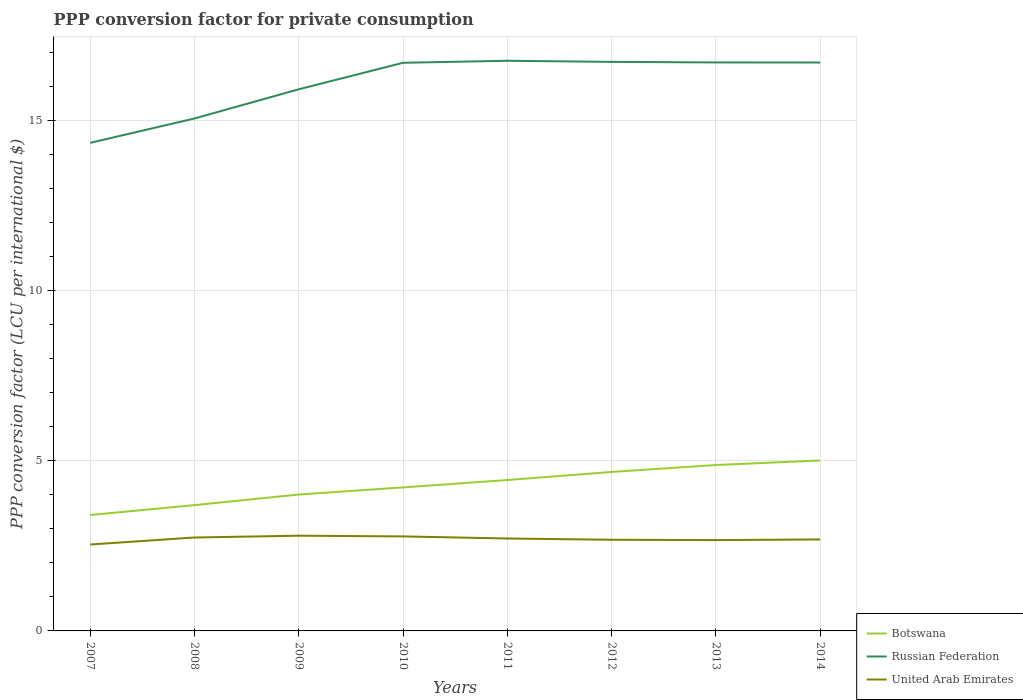Does the line corresponding to Botswana intersect with the line corresponding to United Arab Emirates?
Make the answer very short. No. Across all years, what is the maximum PPP conversion factor for private consumption in Botswana?
Ensure brevity in your answer.  3.41. What is the total PPP conversion factor for private consumption in Russian Federation in the graph?
Your answer should be compact. 0. What is the difference between the highest and the second highest PPP conversion factor for private consumption in Russian Federation?
Provide a short and direct response. 2.41. What is the difference between the highest and the lowest PPP conversion factor for private consumption in Russian Federation?
Your response must be concise. 5. How many lines are there?
Your answer should be very brief. 3. How many years are there in the graph?
Offer a terse response. 8. Does the graph contain any zero values?
Ensure brevity in your answer.  No. How many legend labels are there?
Make the answer very short. 3. How are the legend labels stacked?
Offer a very short reply. Vertical. What is the title of the graph?
Your answer should be very brief. PPP conversion factor for private consumption. Does "Latin America(developing only)" appear as one of the legend labels in the graph?
Give a very brief answer. No. What is the label or title of the Y-axis?
Offer a terse response. PPP conversion factor (LCU per international $). What is the PPP conversion factor (LCU per international $) in Botswana in 2007?
Give a very brief answer. 3.41. What is the PPP conversion factor (LCU per international $) in Russian Federation in 2007?
Provide a succinct answer. 14.36. What is the PPP conversion factor (LCU per international $) in United Arab Emirates in 2007?
Provide a succinct answer. 2.54. What is the PPP conversion factor (LCU per international $) of Botswana in 2008?
Keep it short and to the point. 3.7. What is the PPP conversion factor (LCU per international $) in Russian Federation in 2008?
Offer a terse response. 15.07. What is the PPP conversion factor (LCU per international $) of United Arab Emirates in 2008?
Your answer should be compact. 2.75. What is the PPP conversion factor (LCU per international $) of Botswana in 2009?
Offer a terse response. 4.01. What is the PPP conversion factor (LCU per international $) of Russian Federation in 2009?
Provide a short and direct response. 15.93. What is the PPP conversion factor (LCU per international $) in United Arab Emirates in 2009?
Make the answer very short. 2.8. What is the PPP conversion factor (LCU per international $) in Botswana in 2010?
Your response must be concise. 4.22. What is the PPP conversion factor (LCU per international $) of Russian Federation in 2010?
Provide a succinct answer. 16.71. What is the PPP conversion factor (LCU per international $) of United Arab Emirates in 2010?
Keep it short and to the point. 2.78. What is the PPP conversion factor (LCU per international $) of Botswana in 2011?
Offer a very short reply. 4.44. What is the PPP conversion factor (LCU per international $) in Russian Federation in 2011?
Provide a succinct answer. 16.77. What is the PPP conversion factor (LCU per international $) of United Arab Emirates in 2011?
Your answer should be very brief. 2.72. What is the PPP conversion factor (LCU per international $) of Botswana in 2012?
Offer a terse response. 4.68. What is the PPP conversion factor (LCU per international $) of Russian Federation in 2012?
Give a very brief answer. 16.74. What is the PPP conversion factor (LCU per international $) in United Arab Emirates in 2012?
Your answer should be very brief. 2.68. What is the PPP conversion factor (LCU per international $) of Botswana in 2013?
Ensure brevity in your answer.  4.88. What is the PPP conversion factor (LCU per international $) of Russian Federation in 2013?
Offer a terse response. 16.72. What is the PPP conversion factor (LCU per international $) in United Arab Emirates in 2013?
Keep it short and to the point. 2.67. What is the PPP conversion factor (LCU per international $) in Botswana in 2014?
Give a very brief answer. 5.01. What is the PPP conversion factor (LCU per international $) of Russian Federation in 2014?
Make the answer very short. 16.72. What is the PPP conversion factor (LCU per international $) of United Arab Emirates in 2014?
Provide a succinct answer. 2.69. Across all years, what is the maximum PPP conversion factor (LCU per international $) of Botswana?
Offer a terse response. 5.01. Across all years, what is the maximum PPP conversion factor (LCU per international $) in Russian Federation?
Give a very brief answer. 16.77. Across all years, what is the maximum PPP conversion factor (LCU per international $) of United Arab Emirates?
Offer a very short reply. 2.8. Across all years, what is the minimum PPP conversion factor (LCU per international $) in Botswana?
Your answer should be very brief. 3.41. Across all years, what is the minimum PPP conversion factor (LCU per international $) of Russian Federation?
Make the answer very short. 14.36. Across all years, what is the minimum PPP conversion factor (LCU per international $) in United Arab Emirates?
Your answer should be very brief. 2.54. What is the total PPP conversion factor (LCU per international $) of Botswana in the graph?
Provide a short and direct response. 34.35. What is the total PPP conversion factor (LCU per international $) of Russian Federation in the graph?
Give a very brief answer. 129.01. What is the total PPP conversion factor (LCU per international $) in United Arab Emirates in the graph?
Give a very brief answer. 21.63. What is the difference between the PPP conversion factor (LCU per international $) in Botswana in 2007 and that in 2008?
Provide a short and direct response. -0.29. What is the difference between the PPP conversion factor (LCU per international $) of Russian Federation in 2007 and that in 2008?
Provide a succinct answer. -0.72. What is the difference between the PPP conversion factor (LCU per international $) of United Arab Emirates in 2007 and that in 2008?
Offer a terse response. -0.21. What is the difference between the PPP conversion factor (LCU per international $) of Botswana in 2007 and that in 2009?
Your answer should be compact. -0.6. What is the difference between the PPP conversion factor (LCU per international $) of Russian Federation in 2007 and that in 2009?
Offer a terse response. -1.57. What is the difference between the PPP conversion factor (LCU per international $) of United Arab Emirates in 2007 and that in 2009?
Offer a terse response. -0.26. What is the difference between the PPP conversion factor (LCU per international $) in Botswana in 2007 and that in 2010?
Your answer should be very brief. -0.81. What is the difference between the PPP conversion factor (LCU per international $) of Russian Federation in 2007 and that in 2010?
Offer a very short reply. -2.35. What is the difference between the PPP conversion factor (LCU per international $) in United Arab Emirates in 2007 and that in 2010?
Your answer should be compact. -0.24. What is the difference between the PPP conversion factor (LCU per international $) in Botswana in 2007 and that in 2011?
Your response must be concise. -1.03. What is the difference between the PPP conversion factor (LCU per international $) of Russian Federation in 2007 and that in 2011?
Provide a short and direct response. -2.41. What is the difference between the PPP conversion factor (LCU per international $) of United Arab Emirates in 2007 and that in 2011?
Offer a terse response. -0.18. What is the difference between the PPP conversion factor (LCU per international $) in Botswana in 2007 and that in 2012?
Offer a terse response. -1.27. What is the difference between the PPP conversion factor (LCU per international $) in Russian Federation in 2007 and that in 2012?
Provide a short and direct response. -2.38. What is the difference between the PPP conversion factor (LCU per international $) in United Arab Emirates in 2007 and that in 2012?
Offer a very short reply. -0.14. What is the difference between the PPP conversion factor (LCU per international $) in Botswana in 2007 and that in 2013?
Keep it short and to the point. -1.47. What is the difference between the PPP conversion factor (LCU per international $) in Russian Federation in 2007 and that in 2013?
Your answer should be very brief. -2.36. What is the difference between the PPP conversion factor (LCU per international $) in United Arab Emirates in 2007 and that in 2013?
Make the answer very short. -0.13. What is the difference between the PPP conversion factor (LCU per international $) in Botswana in 2007 and that in 2014?
Provide a short and direct response. -1.6. What is the difference between the PPP conversion factor (LCU per international $) in Russian Federation in 2007 and that in 2014?
Your response must be concise. -2.36. What is the difference between the PPP conversion factor (LCU per international $) in United Arab Emirates in 2007 and that in 2014?
Ensure brevity in your answer.  -0.15. What is the difference between the PPP conversion factor (LCU per international $) of Botswana in 2008 and that in 2009?
Make the answer very short. -0.31. What is the difference between the PPP conversion factor (LCU per international $) of Russian Federation in 2008 and that in 2009?
Your response must be concise. -0.86. What is the difference between the PPP conversion factor (LCU per international $) in United Arab Emirates in 2008 and that in 2009?
Your answer should be very brief. -0.05. What is the difference between the PPP conversion factor (LCU per international $) of Botswana in 2008 and that in 2010?
Your answer should be compact. -0.52. What is the difference between the PPP conversion factor (LCU per international $) of Russian Federation in 2008 and that in 2010?
Keep it short and to the point. -1.64. What is the difference between the PPP conversion factor (LCU per international $) in United Arab Emirates in 2008 and that in 2010?
Your answer should be compact. -0.03. What is the difference between the PPP conversion factor (LCU per international $) in Botswana in 2008 and that in 2011?
Your answer should be very brief. -0.74. What is the difference between the PPP conversion factor (LCU per international $) of Russian Federation in 2008 and that in 2011?
Your response must be concise. -1.7. What is the difference between the PPP conversion factor (LCU per international $) in United Arab Emirates in 2008 and that in 2011?
Offer a terse response. 0.03. What is the difference between the PPP conversion factor (LCU per international $) in Botswana in 2008 and that in 2012?
Provide a succinct answer. -0.98. What is the difference between the PPP conversion factor (LCU per international $) in Russian Federation in 2008 and that in 2012?
Your answer should be very brief. -1.66. What is the difference between the PPP conversion factor (LCU per international $) of United Arab Emirates in 2008 and that in 2012?
Your answer should be compact. 0.07. What is the difference between the PPP conversion factor (LCU per international $) in Botswana in 2008 and that in 2013?
Make the answer very short. -1.18. What is the difference between the PPP conversion factor (LCU per international $) of Russian Federation in 2008 and that in 2013?
Your answer should be very brief. -1.65. What is the difference between the PPP conversion factor (LCU per international $) in United Arab Emirates in 2008 and that in 2013?
Provide a succinct answer. 0.08. What is the difference between the PPP conversion factor (LCU per international $) in Botswana in 2008 and that in 2014?
Your answer should be very brief. -1.31. What is the difference between the PPP conversion factor (LCU per international $) of Russian Federation in 2008 and that in 2014?
Ensure brevity in your answer.  -1.65. What is the difference between the PPP conversion factor (LCU per international $) in United Arab Emirates in 2008 and that in 2014?
Your response must be concise. 0.06. What is the difference between the PPP conversion factor (LCU per international $) of Botswana in 2009 and that in 2010?
Provide a succinct answer. -0.21. What is the difference between the PPP conversion factor (LCU per international $) in Russian Federation in 2009 and that in 2010?
Offer a terse response. -0.78. What is the difference between the PPP conversion factor (LCU per international $) of United Arab Emirates in 2009 and that in 2010?
Your answer should be very brief. 0.02. What is the difference between the PPP conversion factor (LCU per international $) of Botswana in 2009 and that in 2011?
Provide a short and direct response. -0.43. What is the difference between the PPP conversion factor (LCU per international $) in Russian Federation in 2009 and that in 2011?
Offer a terse response. -0.84. What is the difference between the PPP conversion factor (LCU per international $) of United Arab Emirates in 2009 and that in 2011?
Your answer should be very brief. 0.08. What is the difference between the PPP conversion factor (LCU per international $) of Botswana in 2009 and that in 2012?
Your answer should be very brief. -0.66. What is the difference between the PPP conversion factor (LCU per international $) of Russian Federation in 2009 and that in 2012?
Your response must be concise. -0.81. What is the difference between the PPP conversion factor (LCU per international $) in United Arab Emirates in 2009 and that in 2012?
Ensure brevity in your answer.  0.12. What is the difference between the PPP conversion factor (LCU per international $) of Botswana in 2009 and that in 2013?
Provide a short and direct response. -0.87. What is the difference between the PPP conversion factor (LCU per international $) in Russian Federation in 2009 and that in 2013?
Your answer should be very brief. -0.79. What is the difference between the PPP conversion factor (LCU per international $) of United Arab Emirates in 2009 and that in 2013?
Your answer should be very brief. 0.13. What is the difference between the PPP conversion factor (LCU per international $) in Botswana in 2009 and that in 2014?
Your answer should be compact. -1. What is the difference between the PPP conversion factor (LCU per international $) of Russian Federation in 2009 and that in 2014?
Offer a very short reply. -0.79. What is the difference between the PPP conversion factor (LCU per international $) of United Arab Emirates in 2009 and that in 2014?
Keep it short and to the point. 0.11. What is the difference between the PPP conversion factor (LCU per international $) in Botswana in 2010 and that in 2011?
Make the answer very short. -0.22. What is the difference between the PPP conversion factor (LCU per international $) of Russian Federation in 2010 and that in 2011?
Offer a terse response. -0.06. What is the difference between the PPP conversion factor (LCU per international $) of United Arab Emirates in 2010 and that in 2011?
Keep it short and to the point. 0.06. What is the difference between the PPP conversion factor (LCU per international $) of Botswana in 2010 and that in 2012?
Ensure brevity in your answer.  -0.45. What is the difference between the PPP conversion factor (LCU per international $) in Russian Federation in 2010 and that in 2012?
Ensure brevity in your answer.  -0.03. What is the difference between the PPP conversion factor (LCU per international $) of United Arab Emirates in 2010 and that in 2012?
Make the answer very short. 0.1. What is the difference between the PPP conversion factor (LCU per international $) of Botswana in 2010 and that in 2013?
Give a very brief answer. -0.66. What is the difference between the PPP conversion factor (LCU per international $) in Russian Federation in 2010 and that in 2013?
Provide a short and direct response. -0.01. What is the difference between the PPP conversion factor (LCU per international $) in United Arab Emirates in 2010 and that in 2013?
Your answer should be very brief. 0.11. What is the difference between the PPP conversion factor (LCU per international $) in Botswana in 2010 and that in 2014?
Give a very brief answer. -0.79. What is the difference between the PPP conversion factor (LCU per international $) of Russian Federation in 2010 and that in 2014?
Your response must be concise. -0.01. What is the difference between the PPP conversion factor (LCU per international $) of United Arab Emirates in 2010 and that in 2014?
Offer a very short reply. 0.09. What is the difference between the PPP conversion factor (LCU per international $) of Botswana in 2011 and that in 2012?
Offer a terse response. -0.24. What is the difference between the PPP conversion factor (LCU per international $) in Russian Federation in 2011 and that in 2012?
Offer a terse response. 0.03. What is the difference between the PPP conversion factor (LCU per international $) of United Arab Emirates in 2011 and that in 2012?
Keep it short and to the point. 0.04. What is the difference between the PPP conversion factor (LCU per international $) of Botswana in 2011 and that in 2013?
Provide a succinct answer. -0.44. What is the difference between the PPP conversion factor (LCU per international $) of Russian Federation in 2011 and that in 2013?
Offer a terse response. 0.05. What is the difference between the PPP conversion factor (LCU per international $) in United Arab Emirates in 2011 and that in 2013?
Ensure brevity in your answer.  0.05. What is the difference between the PPP conversion factor (LCU per international $) in Botswana in 2011 and that in 2014?
Make the answer very short. -0.58. What is the difference between the PPP conversion factor (LCU per international $) of Russian Federation in 2011 and that in 2014?
Offer a very short reply. 0.05. What is the difference between the PPP conversion factor (LCU per international $) in United Arab Emirates in 2011 and that in 2014?
Provide a succinct answer. 0.03. What is the difference between the PPP conversion factor (LCU per international $) in Botswana in 2012 and that in 2013?
Offer a very short reply. -0.2. What is the difference between the PPP conversion factor (LCU per international $) in Russian Federation in 2012 and that in 2013?
Provide a short and direct response. 0.02. What is the difference between the PPP conversion factor (LCU per international $) in United Arab Emirates in 2012 and that in 2013?
Keep it short and to the point. 0.01. What is the difference between the PPP conversion factor (LCU per international $) of Botswana in 2012 and that in 2014?
Offer a very short reply. -0.34. What is the difference between the PPP conversion factor (LCU per international $) in Russian Federation in 2012 and that in 2014?
Keep it short and to the point. 0.02. What is the difference between the PPP conversion factor (LCU per international $) of United Arab Emirates in 2012 and that in 2014?
Provide a succinct answer. -0.01. What is the difference between the PPP conversion factor (LCU per international $) of Botswana in 2013 and that in 2014?
Your response must be concise. -0.13. What is the difference between the PPP conversion factor (LCU per international $) in Russian Federation in 2013 and that in 2014?
Ensure brevity in your answer.  0. What is the difference between the PPP conversion factor (LCU per international $) of United Arab Emirates in 2013 and that in 2014?
Make the answer very short. -0.02. What is the difference between the PPP conversion factor (LCU per international $) in Botswana in 2007 and the PPP conversion factor (LCU per international $) in Russian Federation in 2008?
Ensure brevity in your answer.  -11.66. What is the difference between the PPP conversion factor (LCU per international $) of Botswana in 2007 and the PPP conversion factor (LCU per international $) of United Arab Emirates in 2008?
Your response must be concise. 0.66. What is the difference between the PPP conversion factor (LCU per international $) of Russian Federation in 2007 and the PPP conversion factor (LCU per international $) of United Arab Emirates in 2008?
Give a very brief answer. 11.61. What is the difference between the PPP conversion factor (LCU per international $) of Botswana in 2007 and the PPP conversion factor (LCU per international $) of Russian Federation in 2009?
Ensure brevity in your answer.  -12.52. What is the difference between the PPP conversion factor (LCU per international $) of Botswana in 2007 and the PPP conversion factor (LCU per international $) of United Arab Emirates in 2009?
Make the answer very short. 0.61. What is the difference between the PPP conversion factor (LCU per international $) of Russian Federation in 2007 and the PPP conversion factor (LCU per international $) of United Arab Emirates in 2009?
Your response must be concise. 11.55. What is the difference between the PPP conversion factor (LCU per international $) of Botswana in 2007 and the PPP conversion factor (LCU per international $) of Russian Federation in 2010?
Provide a succinct answer. -13.3. What is the difference between the PPP conversion factor (LCU per international $) of Botswana in 2007 and the PPP conversion factor (LCU per international $) of United Arab Emirates in 2010?
Keep it short and to the point. 0.63. What is the difference between the PPP conversion factor (LCU per international $) in Russian Federation in 2007 and the PPP conversion factor (LCU per international $) in United Arab Emirates in 2010?
Offer a terse response. 11.58. What is the difference between the PPP conversion factor (LCU per international $) in Botswana in 2007 and the PPP conversion factor (LCU per international $) in Russian Federation in 2011?
Ensure brevity in your answer.  -13.36. What is the difference between the PPP conversion factor (LCU per international $) in Botswana in 2007 and the PPP conversion factor (LCU per international $) in United Arab Emirates in 2011?
Your response must be concise. 0.69. What is the difference between the PPP conversion factor (LCU per international $) of Russian Federation in 2007 and the PPP conversion factor (LCU per international $) of United Arab Emirates in 2011?
Make the answer very short. 11.64. What is the difference between the PPP conversion factor (LCU per international $) of Botswana in 2007 and the PPP conversion factor (LCU per international $) of Russian Federation in 2012?
Make the answer very short. -13.33. What is the difference between the PPP conversion factor (LCU per international $) in Botswana in 2007 and the PPP conversion factor (LCU per international $) in United Arab Emirates in 2012?
Provide a short and direct response. 0.73. What is the difference between the PPP conversion factor (LCU per international $) of Russian Federation in 2007 and the PPP conversion factor (LCU per international $) of United Arab Emirates in 2012?
Offer a very short reply. 11.67. What is the difference between the PPP conversion factor (LCU per international $) of Botswana in 2007 and the PPP conversion factor (LCU per international $) of Russian Federation in 2013?
Ensure brevity in your answer.  -13.31. What is the difference between the PPP conversion factor (LCU per international $) of Botswana in 2007 and the PPP conversion factor (LCU per international $) of United Arab Emirates in 2013?
Ensure brevity in your answer.  0.74. What is the difference between the PPP conversion factor (LCU per international $) in Russian Federation in 2007 and the PPP conversion factor (LCU per international $) in United Arab Emirates in 2013?
Offer a terse response. 11.68. What is the difference between the PPP conversion factor (LCU per international $) of Botswana in 2007 and the PPP conversion factor (LCU per international $) of Russian Federation in 2014?
Your response must be concise. -13.31. What is the difference between the PPP conversion factor (LCU per international $) in Botswana in 2007 and the PPP conversion factor (LCU per international $) in United Arab Emirates in 2014?
Offer a very short reply. 0.72. What is the difference between the PPP conversion factor (LCU per international $) in Russian Federation in 2007 and the PPP conversion factor (LCU per international $) in United Arab Emirates in 2014?
Make the answer very short. 11.67. What is the difference between the PPP conversion factor (LCU per international $) in Botswana in 2008 and the PPP conversion factor (LCU per international $) in Russian Federation in 2009?
Provide a short and direct response. -12.23. What is the difference between the PPP conversion factor (LCU per international $) in Botswana in 2008 and the PPP conversion factor (LCU per international $) in United Arab Emirates in 2009?
Your answer should be compact. 0.9. What is the difference between the PPP conversion factor (LCU per international $) in Russian Federation in 2008 and the PPP conversion factor (LCU per international $) in United Arab Emirates in 2009?
Provide a short and direct response. 12.27. What is the difference between the PPP conversion factor (LCU per international $) of Botswana in 2008 and the PPP conversion factor (LCU per international $) of Russian Federation in 2010?
Ensure brevity in your answer.  -13.01. What is the difference between the PPP conversion factor (LCU per international $) of Botswana in 2008 and the PPP conversion factor (LCU per international $) of United Arab Emirates in 2010?
Your answer should be very brief. 0.92. What is the difference between the PPP conversion factor (LCU per international $) of Russian Federation in 2008 and the PPP conversion factor (LCU per international $) of United Arab Emirates in 2010?
Make the answer very short. 12.29. What is the difference between the PPP conversion factor (LCU per international $) in Botswana in 2008 and the PPP conversion factor (LCU per international $) in Russian Federation in 2011?
Offer a terse response. -13.07. What is the difference between the PPP conversion factor (LCU per international $) of Botswana in 2008 and the PPP conversion factor (LCU per international $) of United Arab Emirates in 2011?
Offer a very short reply. 0.98. What is the difference between the PPP conversion factor (LCU per international $) of Russian Federation in 2008 and the PPP conversion factor (LCU per international $) of United Arab Emirates in 2011?
Provide a short and direct response. 12.35. What is the difference between the PPP conversion factor (LCU per international $) of Botswana in 2008 and the PPP conversion factor (LCU per international $) of Russian Federation in 2012?
Provide a succinct answer. -13.04. What is the difference between the PPP conversion factor (LCU per international $) of Botswana in 2008 and the PPP conversion factor (LCU per international $) of United Arab Emirates in 2012?
Offer a very short reply. 1.02. What is the difference between the PPP conversion factor (LCU per international $) of Russian Federation in 2008 and the PPP conversion factor (LCU per international $) of United Arab Emirates in 2012?
Provide a succinct answer. 12.39. What is the difference between the PPP conversion factor (LCU per international $) of Botswana in 2008 and the PPP conversion factor (LCU per international $) of Russian Federation in 2013?
Ensure brevity in your answer.  -13.02. What is the difference between the PPP conversion factor (LCU per international $) of Botswana in 2008 and the PPP conversion factor (LCU per international $) of United Arab Emirates in 2013?
Your answer should be compact. 1.03. What is the difference between the PPP conversion factor (LCU per international $) of Russian Federation in 2008 and the PPP conversion factor (LCU per international $) of United Arab Emirates in 2013?
Make the answer very short. 12.4. What is the difference between the PPP conversion factor (LCU per international $) in Botswana in 2008 and the PPP conversion factor (LCU per international $) in Russian Federation in 2014?
Your answer should be compact. -13.02. What is the difference between the PPP conversion factor (LCU per international $) in Russian Federation in 2008 and the PPP conversion factor (LCU per international $) in United Arab Emirates in 2014?
Ensure brevity in your answer.  12.38. What is the difference between the PPP conversion factor (LCU per international $) in Botswana in 2009 and the PPP conversion factor (LCU per international $) in Russian Federation in 2010?
Keep it short and to the point. -12.7. What is the difference between the PPP conversion factor (LCU per international $) of Botswana in 2009 and the PPP conversion factor (LCU per international $) of United Arab Emirates in 2010?
Offer a very short reply. 1.23. What is the difference between the PPP conversion factor (LCU per international $) in Russian Federation in 2009 and the PPP conversion factor (LCU per international $) in United Arab Emirates in 2010?
Ensure brevity in your answer.  13.15. What is the difference between the PPP conversion factor (LCU per international $) in Botswana in 2009 and the PPP conversion factor (LCU per international $) in Russian Federation in 2011?
Give a very brief answer. -12.76. What is the difference between the PPP conversion factor (LCU per international $) in Botswana in 2009 and the PPP conversion factor (LCU per international $) in United Arab Emirates in 2011?
Offer a terse response. 1.29. What is the difference between the PPP conversion factor (LCU per international $) in Russian Federation in 2009 and the PPP conversion factor (LCU per international $) in United Arab Emirates in 2011?
Provide a short and direct response. 13.21. What is the difference between the PPP conversion factor (LCU per international $) in Botswana in 2009 and the PPP conversion factor (LCU per international $) in Russian Federation in 2012?
Give a very brief answer. -12.72. What is the difference between the PPP conversion factor (LCU per international $) in Botswana in 2009 and the PPP conversion factor (LCU per international $) in United Arab Emirates in 2012?
Keep it short and to the point. 1.33. What is the difference between the PPP conversion factor (LCU per international $) in Russian Federation in 2009 and the PPP conversion factor (LCU per international $) in United Arab Emirates in 2012?
Keep it short and to the point. 13.25. What is the difference between the PPP conversion factor (LCU per international $) of Botswana in 2009 and the PPP conversion factor (LCU per international $) of Russian Federation in 2013?
Ensure brevity in your answer.  -12.71. What is the difference between the PPP conversion factor (LCU per international $) in Botswana in 2009 and the PPP conversion factor (LCU per international $) in United Arab Emirates in 2013?
Your response must be concise. 1.34. What is the difference between the PPP conversion factor (LCU per international $) in Russian Federation in 2009 and the PPP conversion factor (LCU per international $) in United Arab Emirates in 2013?
Offer a very short reply. 13.26. What is the difference between the PPP conversion factor (LCU per international $) in Botswana in 2009 and the PPP conversion factor (LCU per international $) in Russian Federation in 2014?
Provide a succinct answer. -12.71. What is the difference between the PPP conversion factor (LCU per international $) in Botswana in 2009 and the PPP conversion factor (LCU per international $) in United Arab Emirates in 2014?
Offer a very short reply. 1.32. What is the difference between the PPP conversion factor (LCU per international $) of Russian Federation in 2009 and the PPP conversion factor (LCU per international $) of United Arab Emirates in 2014?
Your response must be concise. 13.24. What is the difference between the PPP conversion factor (LCU per international $) in Botswana in 2010 and the PPP conversion factor (LCU per international $) in Russian Federation in 2011?
Make the answer very short. -12.55. What is the difference between the PPP conversion factor (LCU per international $) in Botswana in 2010 and the PPP conversion factor (LCU per international $) in United Arab Emirates in 2011?
Offer a very short reply. 1.5. What is the difference between the PPP conversion factor (LCU per international $) of Russian Federation in 2010 and the PPP conversion factor (LCU per international $) of United Arab Emirates in 2011?
Offer a very short reply. 13.99. What is the difference between the PPP conversion factor (LCU per international $) of Botswana in 2010 and the PPP conversion factor (LCU per international $) of Russian Federation in 2012?
Give a very brief answer. -12.52. What is the difference between the PPP conversion factor (LCU per international $) in Botswana in 2010 and the PPP conversion factor (LCU per international $) in United Arab Emirates in 2012?
Ensure brevity in your answer.  1.54. What is the difference between the PPP conversion factor (LCU per international $) in Russian Federation in 2010 and the PPP conversion factor (LCU per international $) in United Arab Emirates in 2012?
Provide a succinct answer. 14.03. What is the difference between the PPP conversion factor (LCU per international $) in Botswana in 2010 and the PPP conversion factor (LCU per international $) in Russian Federation in 2013?
Make the answer very short. -12.5. What is the difference between the PPP conversion factor (LCU per international $) in Botswana in 2010 and the PPP conversion factor (LCU per international $) in United Arab Emirates in 2013?
Offer a terse response. 1.55. What is the difference between the PPP conversion factor (LCU per international $) of Russian Federation in 2010 and the PPP conversion factor (LCU per international $) of United Arab Emirates in 2013?
Your answer should be compact. 14.04. What is the difference between the PPP conversion factor (LCU per international $) of Botswana in 2010 and the PPP conversion factor (LCU per international $) of Russian Federation in 2014?
Your answer should be compact. -12.5. What is the difference between the PPP conversion factor (LCU per international $) in Botswana in 2010 and the PPP conversion factor (LCU per international $) in United Arab Emirates in 2014?
Provide a succinct answer. 1.53. What is the difference between the PPP conversion factor (LCU per international $) of Russian Federation in 2010 and the PPP conversion factor (LCU per international $) of United Arab Emirates in 2014?
Your answer should be compact. 14.02. What is the difference between the PPP conversion factor (LCU per international $) in Botswana in 2011 and the PPP conversion factor (LCU per international $) in Russian Federation in 2012?
Your response must be concise. -12.3. What is the difference between the PPP conversion factor (LCU per international $) in Botswana in 2011 and the PPP conversion factor (LCU per international $) in United Arab Emirates in 2012?
Your answer should be very brief. 1.76. What is the difference between the PPP conversion factor (LCU per international $) of Russian Federation in 2011 and the PPP conversion factor (LCU per international $) of United Arab Emirates in 2012?
Provide a succinct answer. 14.09. What is the difference between the PPP conversion factor (LCU per international $) in Botswana in 2011 and the PPP conversion factor (LCU per international $) in Russian Federation in 2013?
Offer a very short reply. -12.28. What is the difference between the PPP conversion factor (LCU per international $) of Botswana in 2011 and the PPP conversion factor (LCU per international $) of United Arab Emirates in 2013?
Ensure brevity in your answer.  1.77. What is the difference between the PPP conversion factor (LCU per international $) of Russian Federation in 2011 and the PPP conversion factor (LCU per international $) of United Arab Emirates in 2013?
Keep it short and to the point. 14.1. What is the difference between the PPP conversion factor (LCU per international $) of Botswana in 2011 and the PPP conversion factor (LCU per international $) of Russian Federation in 2014?
Ensure brevity in your answer.  -12.28. What is the difference between the PPP conversion factor (LCU per international $) of Botswana in 2011 and the PPP conversion factor (LCU per international $) of United Arab Emirates in 2014?
Your answer should be compact. 1.75. What is the difference between the PPP conversion factor (LCU per international $) of Russian Federation in 2011 and the PPP conversion factor (LCU per international $) of United Arab Emirates in 2014?
Offer a very short reply. 14.08. What is the difference between the PPP conversion factor (LCU per international $) in Botswana in 2012 and the PPP conversion factor (LCU per international $) in Russian Federation in 2013?
Offer a very short reply. -12.04. What is the difference between the PPP conversion factor (LCU per international $) of Botswana in 2012 and the PPP conversion factor (LCU per international $) of United Arab Emirates in 2013?
Offer a very short reply. 2. What is the difference between the PPP conversion factor (LCU per international $) of Russian Federation in 2012 and the PPP conversion factor (LCU per international $) of United Arab Emirates in 2013?
Ensure brevity in your answer.  14.06. What is the difference between the PPP conversion factor (LCU per international $) of Botswana in 2012 and the PPP conversion factor (LCU per international $) of Russian Federation in 2014?
Give a very brief answer. -12.04. What is the difference between the PPP conversion factor (LCU per international $) in Botswana in 2012 and the PPP conversion factor (LCU per international $) in United Arab Emirates in 2014?
Offer a terse response. 1.99. What is the difference between the PPP conversion factor (LCU per international $) of Russian Federation in 2012 and the PPP conversion factor (LCU per international $) of United Arab Emirates in 2014?
Provide a succinct answer. 14.05. What is the difference between the PPP conversion factor (LCU per international $) of Botswana in 2013 and the PPP conversion factor (LCU per international $) of Russian Federation in 2014?
Provide a succinct answer. -11.84. What is the difference between the PPP conversion factor (LCU per international $) of Botswana in 2013 and the PPP conversion factor (LCU per international $) of United Arab Emirates in 2014?
Your answer should be compact. 2.19. What is the difference between the PPP conversion factor (LCU per international $) in Russian Federation in 2013 and the PPP conversion factor (LCU per international $) in United Arab Emirates in 2014?
Ensure brevity in your answer.  14.03. What is the average PPP conversion factor (LCU per international $) in Botswana per year?
Offer a terse response. 4.29. What is the average PPP conversion factor (LCU per international $) of Russian Federation per year?
Your answer should be very brief. 16.13. What is the average PPP conversion factor (LCU per international $) in United Arab Emirates per year?
Provide a succinct answer. 2.7. In the year 2007, what is the difference between the PPP conversion factor (LCU per international $) in Botswana and PPP conversion factor (LCU per international $) in Russian Federation?
Your response must be concise. -10.95. In the year 2007, what is the difference between the PPP conversion factor (LCU per international $) in Botswana and PPP conversion factor (LCU per international $) in United Arab Emirates?
Offer a terse response. 0.87. In the year 2007, what is the difference between the PPP conversion factor (LCU per international $) in Russian Federation and PPP conversion factor (LCU per international $) in United Arab Emirates?
Provide a succinct answer. 11.81. In the year 2008, what is the difference between the PPP conversion factor (LCU per international $) in Botswana and PPP conversion factor (LCU per international $) in Russian Federation?
Give a very brief answer. -11.37. In the year 2008, what is the difference between the PPP conversion factor (LCU per international $) in Botswana and PPP conversion factor (LCU per international $) in United Arab Emirates?
Your answer should be very brief. 0.95. In the year 2008, what is the difference between the PPP conversion factor (LCU per international $) in Russian Federation and PPP conversion factor (LCU per international $) in United Arab Emirates?
Make the answer very short. 12.32. In the year 2009, what is the difference between the PPP conversion factor (LCU per international $) in Botswana and PPP conversion factor (LCU per international $) in Russian Federation?
Offer a terse response. -11.92. In the year 2009, what is the difference between the PPP conversion factor (LCU per international $) of Botswana and PPP conversion factor (LCU per international $) of United Arab Emirates?
Ensure brevity in your answer.  1.21. In the year 2009, what is the difference between the PPP conversion factor (LCU per international $) of Russian Federation and PPP conversion factor (LCU per international $) of United Arab Emirates?
Offer a very short reply. 13.13. In the year 2010, what is the difference between the PPP conversion factor (LCU per international $) of Botswana and PPP conversion factor (LCU per international $) of Russian Federation?
Offer a very short reply. -12.49. In the year 2010, what is the difference between the PPP conversion factor (LCU per international $) of Botswana and PPP conversion factor (LCU per international $) of United Arab Emirates?
Offer a very short reply. 1.44. In the year 2010, what is the difference between the PPP conversion factor (LCU per international $) of Russian Federation and PPP conversion factor (LCU per international $) of United Arab Emirates?
Provide a short and direct response. 13.93. In the year 2011, what is the difference between the PPP conversion factor (LCU per international $) in Botswana and PPP conversion factor (LCU per international $) in Russian Federation?
Your answer should be compact. -12.33. In the year 2011, what is the difference between the PPP conversion factor (LCU per international $) in Botswana and PPP conversion factor (LCU per international $) in United Arab Emirates?
Offer a very short reply. 1.72. In the year 2011, what is the difference between the PPP conversion factor (LCU per international $) in Russian Federation and PPP conversion factor (LCU per international $) in United Arab Emirates?
Offer a terse response. 14.05. In the year 2012, what is the difference between the PPP conversion factor (LCU per international $) in Botswana and PPP conversion factor (LCU per international $) in Russian Federation?
Ensure brevity in your answer.  -12.06. In the year 2012, what is the difference between the PPP conversion factor (LCU per international $) in Botswana and PPP conversion factor (LCU per international $) in United Arab Emirates?
Give a very brief answer. 2. In the year 2012, what is the difference between the PPP conversion factor (LCU per international $) in Russian Federation and PPP conversion factor (LCU per international $) in United Arab Emirates?
Offer a very short reply. 14.06. In the year 2013, what is the difference between the PPP conversion factor (LCU per international $) of Botswana and PPP conversion factor (LCU per international $) of Russian Federation?
Give a very brief answer. -11.84. In the year 2013, what is the difference between the PPP conversion factor (LCU per international $) of Botswana and PPP conversion factor (LCU per international $) of United Arab Emirates?
Your answer should be very brief. 2.21. In the year 2013, what is the difference between the PPP conversion factor (LCU per international $) in Russian Federation and PPP conversion factor (LCU per international $) in United Arab Emirates?
Ensure brevity in your answer.  14.05. In the year 2014, what is the difference between the PPP conversion factor (LCU per international $) of Botswana and PPP conversion factor (LCU per international $) of Russian Federation?
Keep it short and to the point. -11.7. In the year 2014, what is the difference between the PPP conversion factor (LCU per international $) in Botswana and PPP conversion factor (LCU per international $) in United Arab Emirates?
Make the answer very short. 2.32. In the year 2014, what is the difference between the PPP conversion factor (LCU per international $) of Russian Federation and PPP conversion factor (LCU per international $) of United Arab Emirates?
Offer a very short reply. 14.03. What is the ratio of the PPP conversion factor (LCU per international $) in Botswana in 2007 to that in 2008?
Your answer should be compact. 0.92. What is the ratio of the PPP conversion factor (LCU per international $) of Russian Federation in 2007 to that in 2008?
Offer a terse response. 0.95. What is the ratio of the PPP conversion factor (LCU per international $) of United Arab Emirates in 2007 to that in 2008?
Your answer should be very brief. 0.93. What is the ratio of the PPP conversion factor (LCU per international $) of Botswana in 2007 to that in 2009?
Offer a very short reply. 0.85. What is the ratio of the PPP conversion factor (LCU per international $) of Russian Federation in 2007 to that in 2009?
Provide a succinct answer. 0.9. What is the ratio of the PPP conversion factor (LCU per international $) of United Arab Emirates in 2007 to that in 2009?
Your response must be concise. 0.91. What is the ratio of the PPP conversion factor (LCU per international $) of Botswana in 2007 to that in 2010?
Offer a terse response. 0.81. What is the ratio of the PPP conversion factor (LCU per international $) in Russian Federation in 2007 to that in 2010?
Offer a terse response. 0.86. What is the ratio of the PPP conversion factor (LCU per international $) of United Arab Emirates in 2007 to that in 2010?
Offer a terse response. 0.91. What is the ratio of the PPP conversion factor (LCU per international $) in Botswana in 2007 to that in 2011?
Keep it short and to the point. 0.77. What is the ratio of the PPP conversion factor (LCU per international $) in Russian Federation in 2007 to that in 2011?
Make the answer very short. 0.86. What is the ratio of the PPP conversion factor (LCU per international $) of United Arab Emirates in 2007 to that in 2011?
Provide a short and direct response. 0.94. What is the ratio of the PPP conversion factor (LCU per international $) of Botswana in 2007 to that in 2012?
Ensure brevity in your answer.  0.73. What is the ratio of the PPP conversion factor (LCU per international $) of Russian Federation in 2007 to that in 2012?
Keep it short and to the point. 0.86. What is the ratio of the PPP conversion factor (LCU per international $) in United Arab Emirates in 2007 to that in 2012?
Your answer should be compact. 0.95. What is the ratio of the PPP conversion factor (LCU per international $) of Botswana in 2007 to that in 2013?
Give a very brief answer. 0.7. What is the ratio of the PPP conversion factor (LCU per international $) of Russian Federation in 2007 to that in 2013?
Make the answer very short. 0.86. What is the ratio of the PPP conversion factor (LCU per international $) in United Arab Emirates in 2007 to that in 2013?
Your answer should be compact. 0.95. What is the ratio of the PPP conversion factor (LCU per international $) of Botswana in 2007 to that in 2014?
Provide a succinct answer. 0.68. What is the ratio of the PPP conversion factor (LCU per international $) of Russian Federation in 2007 to that in 2014?
Give a very brief answer. 0.86. What is the ratio of the PPP conversion factor (LCU per international $) in United Arab Emirates in 2007 to that in 2014?
Provide a short and direct response. 0.94. What is the ratio of the PPP conversion factor (LCU per international $) in Botswana in 2008 to that in 2009?
Make the answer very short. 0.92. What is the ratio of the PPP conversion factor (LCU per international $) of Russian Federation in 2008 to that in 2009?
Provide a succinct answer. 0.95. What is the ratio of the PPP conversion factor (LCU per international $) of United Arab Emirates in 2008 to that in 2009?
Ensure brevity in your answer.  0.98. What is the ratio of the PPP conversion factor (LCU per international $) of Botswana in 2008 to that in 2010?
Keep it short and to the point. 0.88. What is the ratio of the PPP conversion factor (LCU per international $) of Russian Federation in 2008 to that in 2010?
Your answer should be very brief. 0.9. What is the ratio of the PPP conversion factor (LCU per international $) of Botswana in 2008 to that in 2011?
Keep it short and to the point. 0.83. What is the ratio of the PPP conversion factor (LCU per international $) in Russian Federation in 2008 to that in 2011?
Your answer should be very brief. 0.9. What is the ratio of the PPP conversion factor (LCU per international $) of United Arab Emirates in 2008 to that in 2011?
Keep it short and to the point. 1.01. What is the ratio of the PPP conversion factor (LCU per international $) of Botswana in 2008 to that in 2012?
Offer a very short reply. 0.79. What is the ratio of the PPP conversion factor (LCU per international $) of Russian Federation in 2008 to that in 2012?
Give a very brief answer. 0.9. What is the ratio of the PPP conversion factor (LCU per international $) in Botswana in 2008 to that in 2013?
Your response must be concise. 0.76. What is the ratio of the PPP conversion factor (LCU per international $) of Russian Federation in 2008 to that in 2013?
Offer a very short reply. 0.9. What is the ratio of the PPP conversion factor (LCU per international $) of United Arab Emirates in 2008 to that in 2013?
Provide a succinct answer. 1.03. What is the ratio of the PPP conversion factor (LCU per international $) in Botswana in 2008 to that in 2014?
Make the answer very short. 0.74. What is the ratio of the PPP conversion factor (LCU per international $) of Russian Federation in 2008 to that in 2014?
Provide a succinct answer. 0.9. What is the ratio of the PPP conversion factor (LCU per international $) in United Arab Emirates in 2008 to that in 2014?
Offer a terse response. 1.02. What is the ratio of the PPP conversion factor (LCU per international $) of Botswana in 2009 to that in 2010?
Give a very brief answer. 0.95. What is the ratio of the PPP conversion factor (LCU per international $) of Russian Federation in 2009 to that in 2010?
Provide a succinct answer. 0.95. What is the ratio of the PPP conversion factor (LCU per international $) of United Arab Emirates in 2009 to that in 2010?
Make the answer very short. 1.01. What is the ratio of the PPP conversion factor (LCU per international $) in Botswana in 2009 to that in 2011?
Ensure brevity in your answer.  0.9. What is the ratio of the PPP conversion factor (LCU per international $) of United Arab Emirates in 2009 to that in 2011?
Provide a succinct answer. 1.03. What is the ratio of the PPP conversion factor (LCU per international $) of Botswana in 2009 to that in 2012?
Keep it short and to the point. 0.86. What is the ratio of the PPP conversion factor (LCU per international $) of Russian Federation in 2009 to that in 2012?
Your response must be concise. 0.95. What is the ratio of the PPP conversion factor (LCU per international $) in United Arab Emirates in 2009 to that in 2012?
Your answer should be compact. 1.04. What is the ratio of the PPP conversion factor (LCU per international $) in Botswana in 2009 to that in 2013?
Your answer should be very brief. 0.82. What is the ratio of the PPP conversion factor (LCU per international $) of Russian Federation in 2009 to that in 2013?
Offer a very short reply. 0.95. What is the ratio of the PPP conversion factor (LCU per international $) of United Arab Emirates in 2009 to that in 2013?
Give a very brief answer. 1.05. What is the ratio of the PPP conversion factor (LCU per international $) of Botswana in 2009 to that in 2014?
Your answer should be very brief. 0.8. What is the ratio of the PPP conversion factor (LCU per international $) of Russian Federation in 2009 to that in 2014?
Keep it short and to the point. 0.95. What is the ratio of the PPP conversion factor (LCU per international $) in United Arab Emirates in 2009 to that in 2014?
Offer a very short reply. 1.04. What is the ratio of the PPP conversion factor (LCU per international $) of Botswana in 2010 to that in 2011?
Your answer should be very brief. 0.95. What is the ratio of the PPP conversion factor (LCU per international $) in United Arab Emirates in 2010 to that in 2011?
Offer a very short reply. 1.02. What is the ratio of the PPP conversion factor (LCU per international $) of Botswana in 2010 to that in 2012?
Your answer should be compact. 0.9. What is the ratio of the PPP conversion factor (LCU per international $) of United Arab Emirates in 2010 to that in 2012?
Give a very brief answer. 1.04. What is the ratio of the PPP conversion factor (LCU per international $) of Botswana in 2010 to that in 2013?
Offer a very short reply. 0.87. What is the ratio of the PPP conversion factor (LCU per international $) in Russian Federation in 2010 to that in 2013?
Your response must be concise. 1. What is the ratio of the PPP conversion factor (LCU per international $) of United Arab Emirates in 2010 to that in 2013?
Your answer should be compact. 1.04. What is the ratio of the PPP conversion factor (LCU per international $) of Botswana in 2010 to that in 2014?
Your answer should be compact. 0.84. What is the ratio of the PPP conversion factor (LCU per international $) in Russian Federation in 2010 to that in 2014?
Your response must be concise. 1. What is the ratio of the PPP conversion factor (LCU per international $) of United Arab Emirates in 2010 to that in 2014?
Your answer should be compact. 1.03. What is the ratio of the PPP conversion factor (LCU per international $) in Botswana in 2011 to that in 2012?
Offer a very short reply. 0.95. What is the ratio of the PPP conversion factor (LCU per international $) in Russian Federation in 2011 to that in 2012?
Offer a terse response. 1. What is the ratio of the PPP conversion factor (LCU per international $) in Botswana in 2011 to that in 2013?
Your answer should be compact. 0.91. What is the ratio of the PPP conversion factor (LCU per international $) in Russian Federation in 2011 to that in 2013?
Offer a terse response. 1. What is the ratio of the PPP conversion factor (LCU per international $) of United Arab Emirates in 2011 to that in 2013?
Make the answer very short. 1.02. What is the ratio of the PPP conversion factor (LCU per international $) of Botswana in 2011 to that in 2014?
Give a very brief answer. 0.89. What is the ratio of the PPP conversion factor (LCU per international $) of Russian Federation in 2011 to that in 2014?
Keep it short and to the point. 1. What is the ratio of the PPP conversion factor (LCU per international $) of United Arab Emirates in 2011 to that in 2014?
Your response must be concise. 1.01. What is the ratio of the PPP conversion factor (LCU per international $) of Botswana in 2012 to that in 2014?
Provide a succinct answer. 0.93. What is the ratio of the PPP conversion factor (LCU per international $) of United Arab Emirates in 2012 to that in 2014?
Your response must be concise. 1. What is the ratio of the PPP conversion factor (LCU per international $) in Botswana in 2013 to that in 2014?
Provide a short and direct response. 0.97. What is the ratio of the PPP conversion factor (LCU per international $) in Russian Federation in 2013 to that in 2014?
Provide a succinct answer. 1. What is the difference between the highest and the second highest PPP conversion factor (LCU per international $) of Botswana?
Keep it short and to the point. 0.13. What is the difference between the highest and the second highest PPP conversion factor (LCU per international $) of Russian Federation?
Your answer should be compact. 0.03. What is the difference between the highest and the second highest PPP conversion factor (LCU per international $) in United Arab Emirates?
Provide a succinct answer. 0.02. What is the difference between the highest and the lowest PPP conversion factor (LCU per international $) in Botswana?
Provide a succinct answer. 1.6. What is the difference between the highest and the lowest PPP conversion factor (LCU per international $) of Russian Federation?
Offer a very short reply. 2.41. What is the difference between the highest and the lowest PPP conversion factor (LCU per international $) in United Arab Emirates?
Your response must be concise. 0.26. 